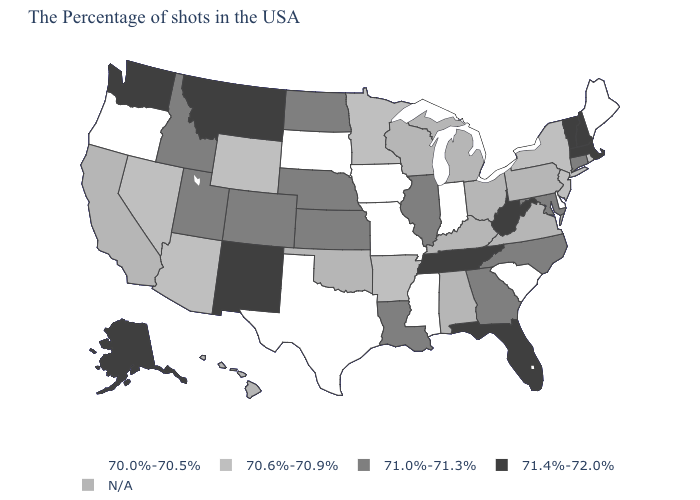Among the states that border Montana , which have the lowest value?
Write a very short answer. South Dakota. Name the states that have a value in the range 70.6%-70.9%?
Be succinct. Rhode Island, New York, New Jersey, Arkansas, Minnesota, Wyoming, Arizona, Nevada. Does Kansas have the highest value in the MidWest?
Concise answer only. Yes. Name the states that have a value in the range 70.0%-70.5%?
Short answer required. Maine, Delaware, South Carolina, Indiana, Mississippi, Missouri, Iowa, Texas, South Dakota, Oregon. What is the value of Tennessee?
Quick response, please. 71.4%-72.0%. Name the states that have a value in the range 70.0%-70.5%?
Give a very brief answer. Maine, Delaware, South Carolina, Indiana, Mississippi, Missouri, Iowa, Texas, South Dakota, Oregon. What is the value of Louisiana?
Answer briefly. 71.0%-71.3%. What is the value of Nevada?
Short answer required. 70.6%-70.9%. What is the value of Ohio?
Quick response, please. N/A. What is the value of Kansas?
Quick response, please. 71.0%-71.3%. Which states hav the highest value in the MidWest?
Quick response, please. Illinois, Kansas, Nebraska, North Dakota. What is the value of Minnesota?
Give a very brief answer. 70.6%-70.9%. Among the states that border Kentucky , does West Virginia have the highest value?
Answer briefly. Yes. What is the lowest value in the USA?
Be succinct. 70.0%-70.5%. Name the states that have a value in the range 70.6%-70.9%?
Quick response, please. Rhode Island, New York, New Jersey, Arkansas, Minnesota, Wyoming, Arizona, Nevada. 